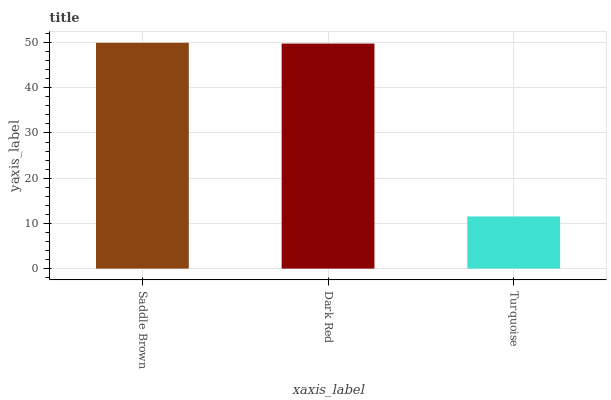Is Turquoise the minimum?
Answer yes or no. Yes. Is Saddle Brown the maximum?
Answer yes or no. Yes. Is Dark Red the minimum?
Answer yes or no. No. Is Dark Red the maximum?
Answer yes or no. No. Is Saddle Brown greater than Dark Red?
Answer yes or no. Yes. Is Dark Red less than Saddle Brown?
Answer yes or no. Yes. Is Dark Red greater than Saddle Brown?
Answer yes or no. No. Is Saddle Brown less than Dark Red?
Answer yes or no. No. Is Dark Red the high median?
Answer yes or no. Yes. Is Dark Red the low median?
Answer yes or no. Yes. Is Saddle Brown the high median?
Answer yes or no. No. Is Turquoise the low median?
Answer yes or no. No. 